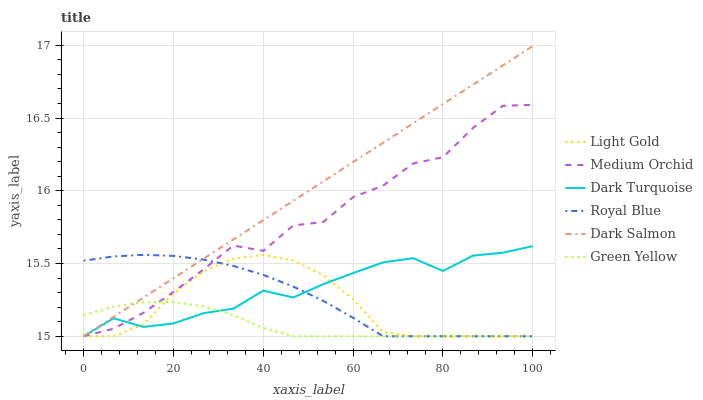Does Green Yellow have the minimum area under the curve?
Answer yes or no. Yes. Does Dark Salmon have the maximum area under the curve?
Answer yes or no. Yes. Does Medium Orchid have the minimum area under the curve?
Answer yes or no. No. Does Medium Orchid have the maximum area under the curve?
Answer yes or no. No. Is Dark Salmon the smoothest?
Answer yes or no. Yes. Is Medium Orchid the roughest?
Answer yes or no. Yes. Is Medium Orchid the smoothest?
Answer yes or no. No. Is Dark Salmon the roughest?
Answer yes or no. No. Does Medium Orchid have the highest value?
Answer yes or no. No. 